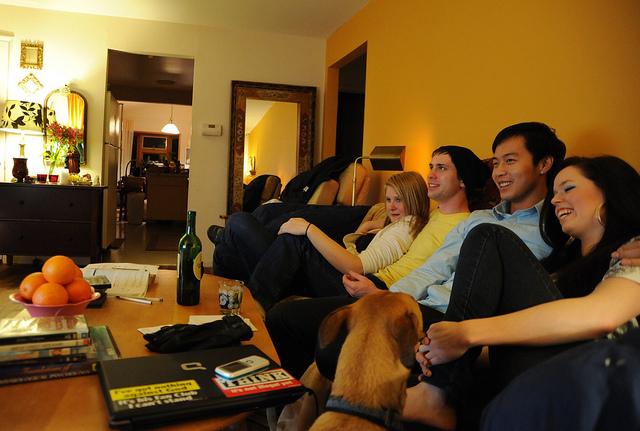What is the dog doing?
Short answer required. Sitting. Is this an affectionate group that appreciates closeness?
Write a very short answer. Yes. Are the people on the right sitting in chairs or booths?
Short answer required. Chairs. What kind of laptop computer is there?
Short answer required. Compaq. How many people are on the couch?
Give a very brief answer. 4. Is this someone's home?
Be succinct. Yes. Is this an airport?
Write a very short answer. No. What is the woman in the foreground doing with the dog?
Keep it brief. Nothing. Are the people watching TV?
Keep it brief. Yes. What fruit is in the bowl?
Keep it brief. Oranges. How many people have boxes on their laps?
Answer briefly. 0. How many oranges are in the bowl?
Write a very short answer. 5. 